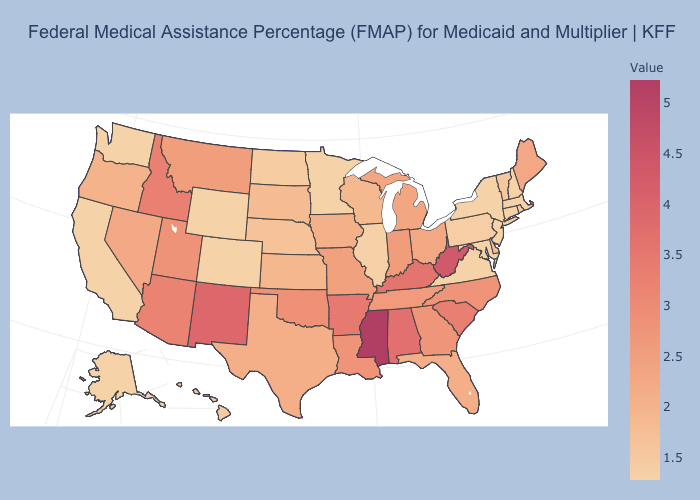Which states have the lowest value in the West?
Give a very brief answer. Alaska, California, Colorado, Washington, Wyoming. Does the map have missing data?
Keep it brief. No. Among the states that border New Mexico , which have the lowest value?
Short answer required. Colorado. Among the states that border Tennessee , which have the highest value?
Keep it brief. Mississippi. 